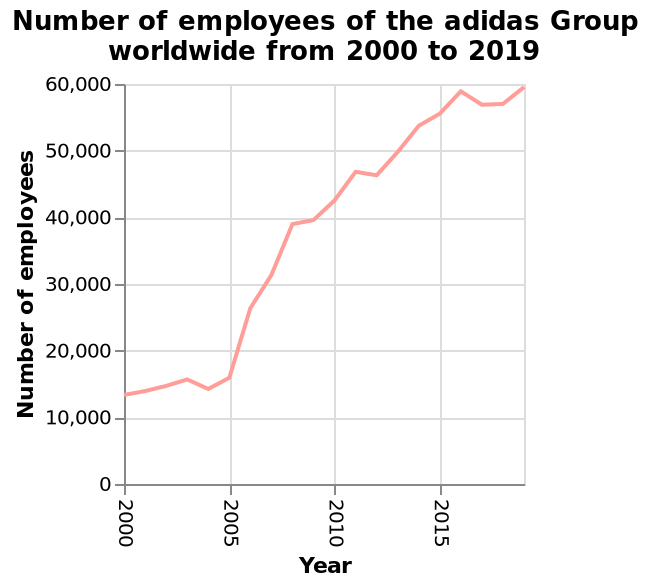<image>
What does the x-axis represent on the line graph?  The x-axis represents the years from 2000 to 2015. Has the number of employees consistently increased since 2005? Yes, the number of employees has consistently increased since 2005. 